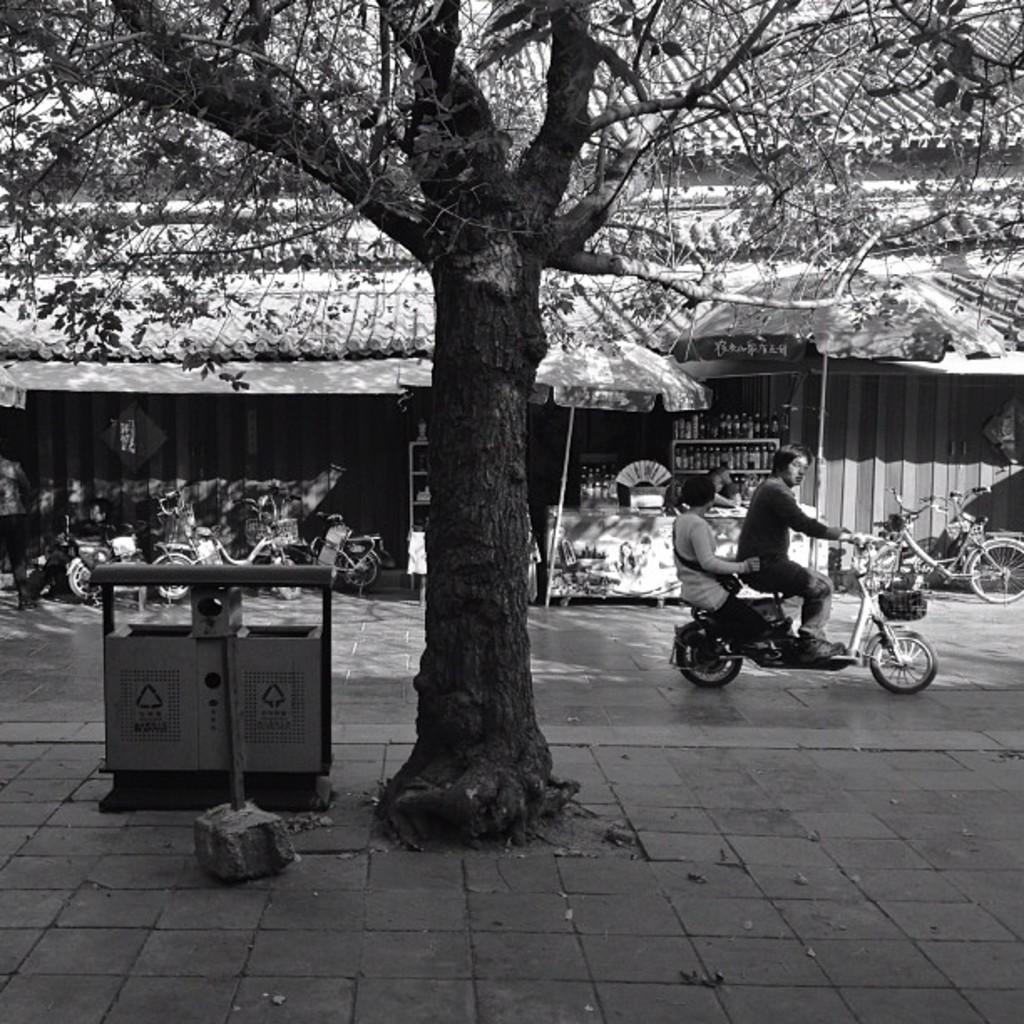Can you describe this image briefly? This picture shows a tree on the side of the road. There are two members on the vehicle. There are some vehicles parked and a building, building in the background. 